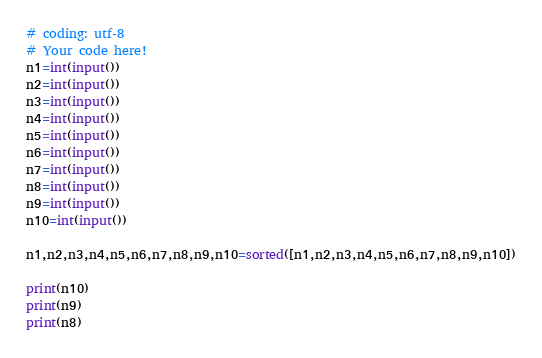<code> <loc_0><loc_0><loc_500><loc_500><_Python_># coding: utf-8
# Your code here!
n1=int(input())
n2=int(input())
n3=int(input())
n4=int(input())
n5=int(input())
n6=int(input())
n7=int(input())
n8=int(input())
n9=int(input())
n10=int(input())

n1,n2,n3,n4,n5,n6,n7,n8,n9,n10=sorted([n1,n2,n3,n4,n5,n6,n7,n8,n9,n10])

print(n10)
print(n9)
print(n8)
</code> 